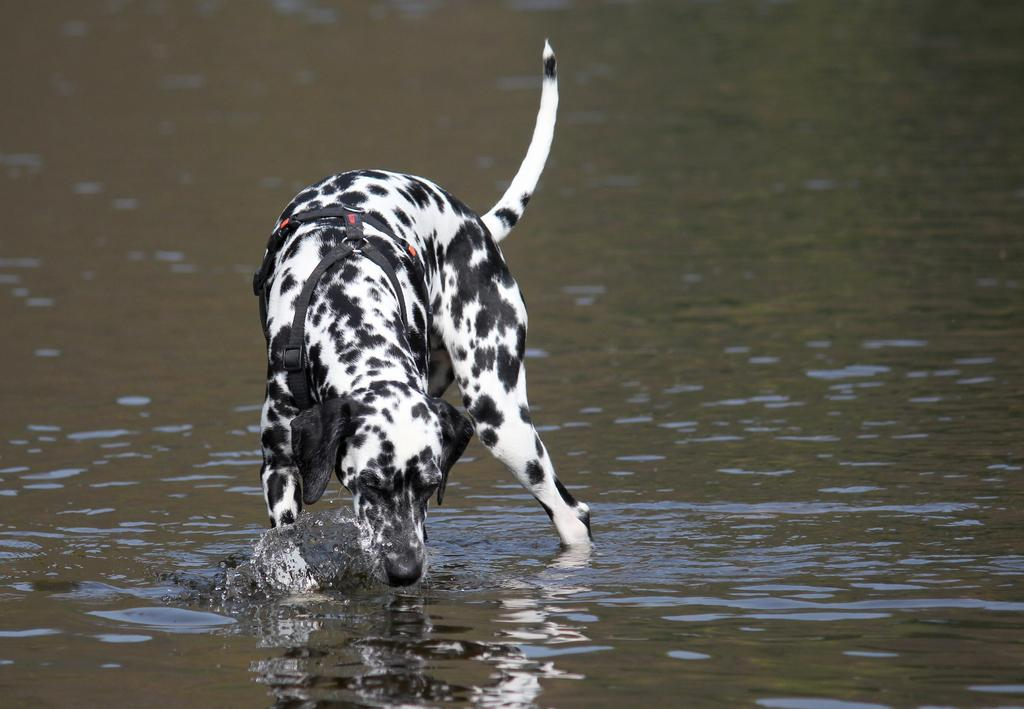What is the main subject of the image? There is a dog in the center of the image. What can be seen at the bottom of the image? There is water visible at the bottom of the image. What type of picture is hanging on the wall in the image? There is no mention of a picture hanging on the wall in the image; the main subjects are the dog and the water. 